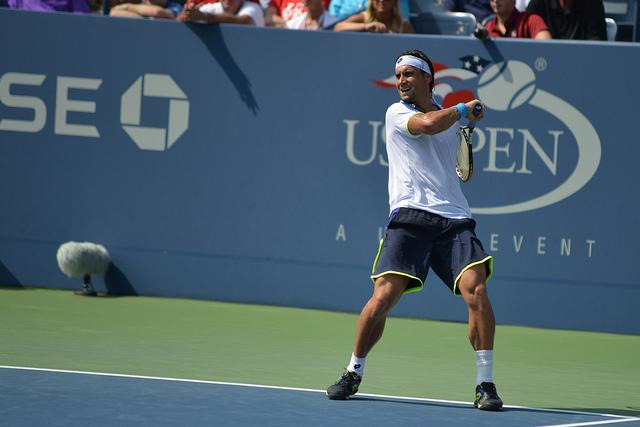Why does he have the racquet behind him? Please explain your reasoning. strike ball. While and immediately after doing this, a person's arm is often extended out from the body in a way that helps them keep their balance. 